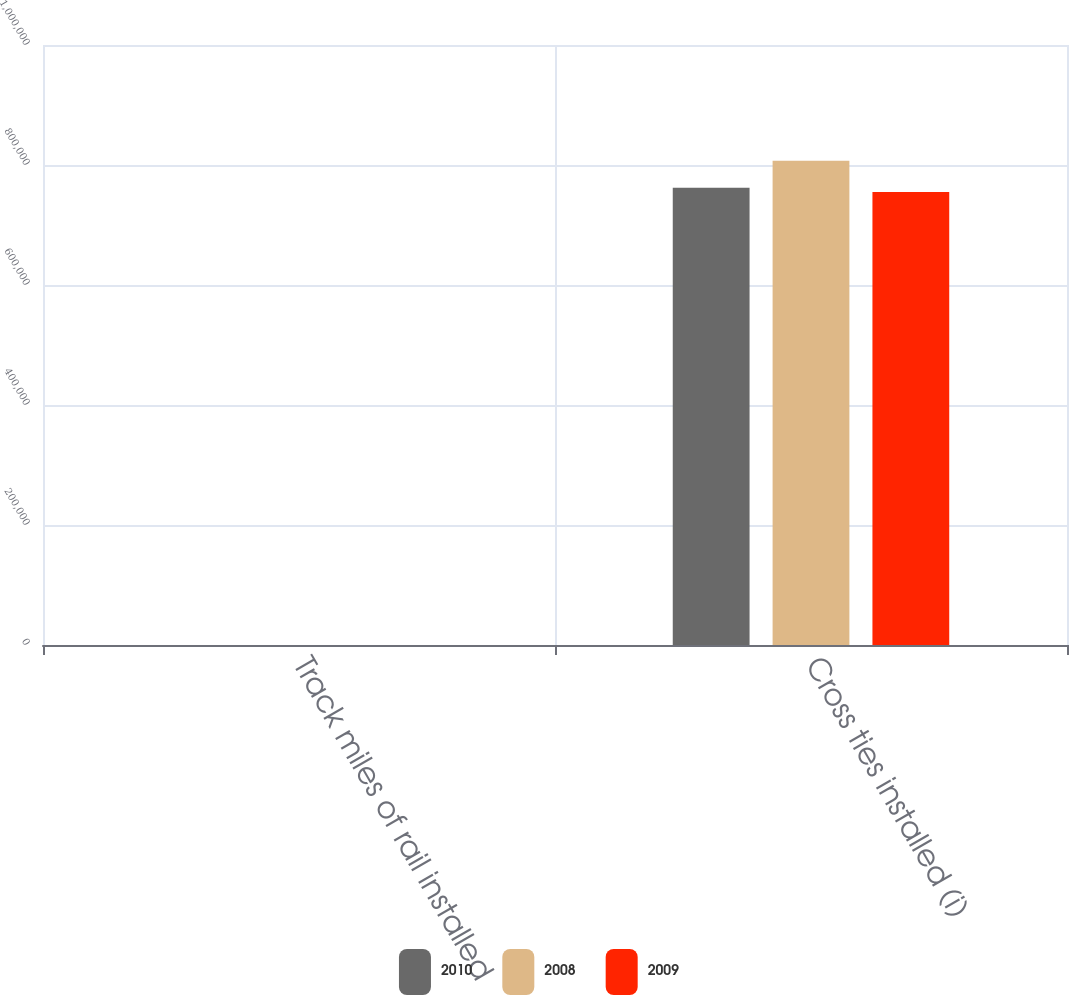Convert chart to OTSL. <chart><loc_0><loc_0><loc_500><loc_500><stacked_bar_chart><ecel><fcel>Track miles of rail installed<fcel>Cross ties installed (i)<nl><fcel>2010<fcel>81<fcel>762228<nl><fcel>2008<fcel>120<fcel>806908<nl><fcel>2009<fcel>49<fcel>754900<nl></chart> 